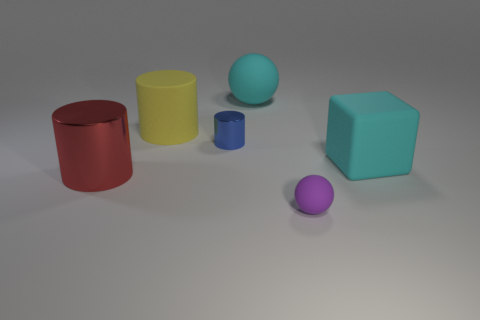Add 2 large cylinders. How many objects exist? 8 Subtract all balls. How many objects are left? 4 Subtract 0 purple blocks. How many objects are left? 6 Subtract all big cyan objects. Subtract all large gray metal things. How many objects are left? 4 Add 1 big cyan rubber cubes. How many big cyan rubber cubes are left? 2 Add 3 big metallic cylinders. How many big metallic cylinders exist? 4 